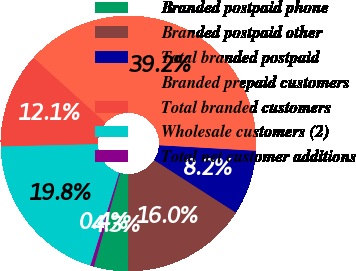Convert chart to OTSL. <chart><loc_0><loc_0><loc_500><loc_500><pie_chart><fcel>Branded postpaid phone<fcel>Branded postpaid other<fcel>Total branded postpaid<fcel>Branded prepaid customers<fcel>Total branded customers<fcel>Wholesale customers (2)<fcel>Total net customer additions<nl><fcel>4.31%<fcel>15.95%<fcel>8.19%<fcel>39.22%<fcel>12.07%<fcel>19.83%<fcel>0.43%<nl></chart> 